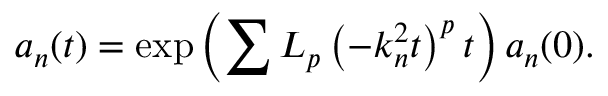Convert formula to latex. <formula><loc_0><loc_0><loc_500><loc_500>a _ { n } ( t ) = \exp \left ( \sum L _ { p } \left ( - k _ { n } ^ { 2 } t \right ) ^ { p } t \right ) a _ { n } ( 0 ) .</formula> 